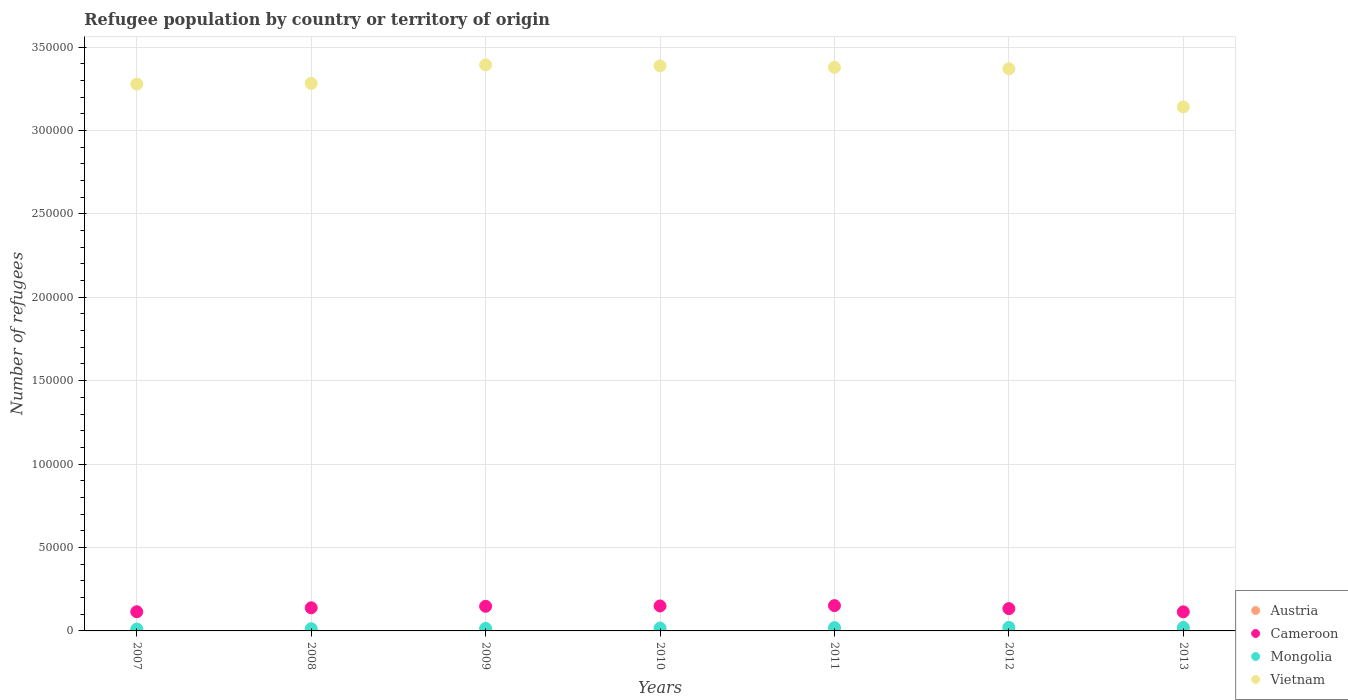How many different coloured dotlines are there?
Offer a very short reply. 4. Is the number of dotlines equal to the number of legend labels?
Your answer should be very brief. Yes. What is the number of refugees in Cameroon in 2008?
Make the answer very short. 1.39e+04. Across all years, what is the minimum number of refugees in Mongolia?
Give a very brief answer. 1101. In which year was the number of refugees in Vietnam minimum?
Give a very brief answer. 2013. What is the total number of refugees in Cameroon in the graph?
Give a very brief answer. 9.51e+04. What is the difference between the number of refugees in Cameroon in 2010 and that in 2013?
Give a very brief answer. 3521. What is the difference between the number of refugees in Austria in 2013 and the number of refugees in Vietnam in 2010?
Offer a very short reply. -3.39e+05. What is the average number of refugees in Cameroon per year?
Keep it short and to the point. 1.36e+04. In the year 2013, what is the difference between the number of refugees in Cameroon and number of refugees in Mongolia?
Ensure brevity in your answer.  9378. What is the ratio of the number of refugees in Austria in 2010 to that in 2012?
Your answer should be very brief. 0.83. Is the number of refugees in Austria in 2009 less than that in 2012?
Your answer should be compact. No. What is the difference between the highest and the second highest number of refugees in Cameroon?
Your response must be concise. 200. What is the difference between the highest and the lowest number of refugees in Mongolia?
Ensure brevity in your answer.  1013. Is the sum of the number of refugees in Austria in 2011 and 2012 greater than the maximum number of refugees in Cameroon across all years?
Your answer should be very brief. No. Is it the case that in every year, the sum of the number of refugees in Cameroon and number of refugees in Vietnam  is greater than the number of refugees in Austria?
Make the answer very short. Yes. Is the number of refugees in Mongolia strictly greater than the number of refugees in Austria over the years?
Provide a succinct answer. Yes. Is the number of refugees in Austria strictly less than the number of refugees in Mongolia over the years?
Provide a succinct answer. Yes. What is the difference between two consecutive major ticks on the Y-axis?
Your answer should be compact. 5.00e+04. Does the graph contain any zero values?
Offer a very short reply. No. Does the graph contain grids?
Your response must be concise. Yes. How many legend labels are there?
Offer a terse response. 4. What is the title of the graph?
Make the answer very short. Refugee population by country or territory of origin. Does "Monaco" appear as one of the legend labels in the graph?
Your answer should be very brief. No. What is the label or title of the Y-axis?
Your answer should be compact. Number of refugees. What is the Number of refugees of Cameroon in 2007?
Ensure brevity in your answer.  1.15e+04. What is the Number of refugees in Mongolia in 2007?
Give a very brief answer. 1101. What is the Number of refugees of Vietnam in 2007?
Your answer should be very brief. 3.28e+05. What is the Number of refugees of Austria in 2008?
Your answer should be compact. 14. What is the Number of refugees of Cameroon in 2008?
Keep it short and to the point. 1.39e+04. What is the Number of refugees of Mongolia in 2008?
Your answer should be compact. 1333. What is the Number of refugees in Vietnam in 2008?
Keep it short and to the point. 3.28e+05. What is the Number of refugees of Austria in 2009?
Give a very brief answer. 12. What is the Number of refugees in Cameroon in 2009?
Make the answer very short. 1.48e+04. What is the Number of refugees in Mongolia in 2009?
Offer a very short reply. 1495. What is the Number of refugees of Vietnam in 2009?
Ensure brevity in your answer.  3.39e+05. What is the Number of refugees of Austria in 2010?
Keep it short and to the point. 10. What is the Number of refugees in Cameroon in 2010?
Give a very brief answer. 1.50e+04. What is the Number of refugees of Mongolia in 2010?
Your answer should be very brief. 1724. What is the Number of refugees in Vietnam in 2010?
Make the answer very short. 3.39e+05. What is the Number of refugees of Cameroon in 2011?
Offer a very short reply. 1.52e+04. What is the Number of refugees of Mongolia in 2011?
Provide a short and direct response. 1985. What is the Number of refugees of Vietnam in 2011?
Your response must be concise. 3.38e+05. What is the Number of refugees of Cameroon in 2012?
Provide a short and direct response. 1.34e+04. What is the Number of refugees in Mongolia in 2012?
Provide a succinct answer. 2114. What is the Number of refugees of Vietnam in 2012?
Ensure brevity in your answer.  3.37e+05. What is the Number of refugees in Austria in 2013?
Your answer should be very brief. 10. What is the Number of refugees of Cameroon in 2013?
Provide a short and direct response. 1.14e+04. What is the Number of refugees of Mongolia in 2013?
Make the answer very short. 2064. What is the Number of refugees in Vietnam in 2013?
Offer a terse response. 3.14e+05. Across all years, what is the maximum Number of refugees in Cameroon?
Provide a succinct answer. 1.52e+04. Across all years, what is the maximum Number of refugees in Mongolia?
Your response must be concise. 2114. Across all years, what is the maximum Number of refugees of Vietnam?
Provide a short and direct response. 3.39e+05. Across all years, what is the minimum Number of refugees in Cameroon?
Provide a succinct answer. 1.14e+04. Across all years, what is the minimum Number of refugees in Mongolia?
Your answer should be very brief. 1101. Across all years, what is the minimum Number of refugees in Vietnam?
Make the answer very short. 3.14e+05. What is the total Number of refugees in Austria in the graph?
Your answer should be compact. 92. What is the total Number of refugees of Cameroon in the graph?
Provide a short and direct response. 9.51e+04. What is the total Number of refugees in Mongolia in the graph?
Keep it short and to the point. 1.18e+04. What is the total Number of refugees in Vietnam in the graph?
Provide a succinct answer. 2.32e+06. What is the difference between the Number of refugees of Cameroon in 2007 and that in 2008?
Keep it short and to the point. -2362. What is the difference between the Number of refugees in Mongolia in 2007 and that in 2008?
Offer a terse response. -232. What is the difference between the Number of refugees of Vietnam in 2007 and that in 2008?
Provide a succinct answer. -407. What is the difference between the Number of refugees in Austria in 2007 and that in 2009?
Provide a succinct answer. 11. What is the difference between the Number of refugees in Cameroon in 2007 and that in 2009?
Keep it short and to the point. -3258. What is the difference between the Number of refugees of Mongolia in 2007 and that in 2009?
Provide a short and direct response. -394. What is the difference between the Number of refugees in Vietnam in 2007 and that in 2009?
Your answer should be compact. -1.15e+04. What is the difference between the Number of refugees of Austria in 2007 and that in 2010?
Keep it short and to the point. 13. What is the difference between the Number of refugees in Cameroon in 2007 and that in 2010?
Your answer should be compact. -3455. What is the difference between the Number of refugees in Mongolia in 2007 and that in 2010?
Make the answer very short. -623. What is the difference between the Number of refugees in Vietnam in 2007 and that in 2010?
Your answer should be very brief. -1.09e+04. What is the difference between the Number of refugees in Cameroon in 2007 and that in 2011?
Your answer should be compact. -3655. What is the difference between the Number of refugees of Mongolia in 2007 and that in 2011?
Keep it short and to the point. -884. What is the difference between the Number of refugees in Vietnam in 2007 and that in 2011?
Offer a very short reply. -1.01e+04. What is the difference between the Number of refugees of Cameroon in 2007 and that in 2012?
Keep it short and to the point. -1874. What is the difference between the Number of refugees in Mongolia in 2007 and that in 2012?
Your answer should be compact. -1013. What is the difference between the Number of refugees of Vietnam in 2007 and that in 2012?
Keep it short and to the point. -9163. What is the difference between the Number of refugees of Austria in 2007 and that in 2013?
Provide a short and direct response. 13. What is the difference between the Number of refugees of Mongolia in 2007 and that in 2013?
Make the answer very short. -963. What is the difference between the Number of refugees of Vietnam in 2007 and that in 2013?
Provide a short and direct response. 1.37e+04. What is the difference between the Number of refugees of Austria in 2008 and that in 2009?
Your response must be concise. 2. What is the difference between the Number of refugees of Cameroon in 2008 and that in 2009?
Ensure brevity in your answer.  -896. What is the difference between the Number of refugees in Mongolia in 2008 and that in 2009?
Keep it short and to the point. -162. What is the difference between the Number of refugees of Vietnam in 2008 and that in 2009?
Offer a very short reply. -1.11e+04. What is the difference between the Number of refugees of Cameroon in 2008 and that in 2010?
Offer a very short reply. -1093. What is the difference between the Number of refugees in Mongolia in 2008 and that in 2010?
Offer a terse response. -391. What is the difference between the Number of refugees of Vietnam in 2008 and that in 2010?
Your response must be concise. -1.05e+04. What is the difference between the Number of refugees in Cameroon in 2008 and that in 2011?
Your answer should be compact. -1293. What is the difference between the Number of refugees in Mongolia in 2008 and that in 2011?
Ensure brevity in your answer.  -652. What is the difference between the Number of refugees of Vietnam in 2008 and that in 2011?
Keep it short and to the point. -9646. What is the difference between the Number of refugees in Austria in 2008 and that in 2012?
Your answer should be very brief. 2. What is the difference between the Number of refugees in Cameroon in 2008 and that in 2012?
Your response must be concise. 488. What is the difference between the Number of refugees of Mongolia in 2008 and that in 2012?
Ensure brevity in your answer.  -781. What is the difference between the Number of refugees in Vietnam in 2008 and that in 2012?
Keep it short and to the point. -8756. What is the difference between the Number of refugees of Cameroon in 2008 and that in 2013?
Your answer should be compact. 2428. What is the difference between the Number of refugees of Mongolia in 2008 and that in 2013?
Offer a terse response. -731. What is the difference between the Number of refugees of Vietnam in 2008 and that in 2013?
Ensure brevity in your answer.  1.41e+04. What is the difference between the Number of refugees of Austria in 2009 and that in 2010?
Your response must be concise. 2. What is the difference between the Number of refugees of Cameroon in 2009 and that in 2010?
Your response must be concise. -197. What is the difference between the Number of refugees in Mongolia in 2009 and that in 2010?
Provide a short and direct response. -229. What is the difference between the Number of refugees in Vietnam in 2009 and that in 2010?
Keep it short and to the point. 591. What is the difference between the Number of refugees of Cameroon in 2009 and that in 2011?
Provide a succinct answer. -397. What is the difference between the Number of refugees in Mongolia in 2009 and that in 2011?
Your answer should be compact. -490. What is the difference between the Number of refugees in Vietnam in 2009 and that in 2011?
Give a very brief answer. 1460. What is the difference between the Number of refugees in Austria in 2009 and that in 2012?
Provide a short and direct response. 0. What is the difference between the Number of refugees of Cameroon in 2009 and that in 2012?
Keep it short and to the point. 1384. What is the difference between the Number of refugees in Mongolia in 2009 and that in 2012?
Your answer should be compact. -619. What is the difference between the Number of refugees in Vietnam in 2009 and that in 2012?
Ensure brevity in your answer.  2350. What is the difference between the Number of refugees of Austria in 2009 and that in 2013?
Your answer should be very brief. 2. What is the difference between the Number of refugees in Cameroon in 2009 and that in 2013?
Give a very brief answer. 3324. What is the difference between the Number of refugees in Mongolia in 2009 and that in 2013?
Offer a very short reply. -569. What is the difference between the Number of refugees of Vietnam in 2009 and that in 2013?
Keep it short and to the point. 2.52e+04. What is the difference between the Number of refugees in Austria in 2010 and that in 2011?
Keep it short and to the point. -1. What is the difference between the Number of refugees of Cameroon in 2010 and that in 2011?
Provide a succinct answer. -200. What is the difference between the Number of refugees of Mongolia in 2010 and that in 2011?
Your answer should be compact. -261. What is the difference between the Number of refugees of Vietnam in 2010 and that in 2011?
Provide a short and direct response. 869. What is the difference between the Number of refugees in Cameroon in 2010 and that in 2012?
Provide a succinct answer. 1581. What is the difference between the Number of refugees in Mongolia in 2010 and that in 2012?
Offer a terse response. -390. What is the difference between the Number of refugees in Vietnam in 2010 and that in 2012?
Ensure brevity in your answer.  1759. What is the difference between the Number of refugees in Cameroon in 2010 and that in 2013?
Your answer should be very brief. 3521. What is the difference between the Number of refugees in Mongolia in 2010 and that in 2013?
Provide a short and direct response. -340. What is the difference between the Number of refugees of Vietnam in 2010 and that in 2013?
Offer a terse response. 2.46e+04. What is the difference between the Number of refugees of Austria in 2011 and that in 2012?
Keep it short and to the point. -1. What is the difference between the Number of refugees in Cameroon in 2011 and that in 2012?
Ensure brevity in your answer.  1781. What is the difference between the Number of refugees in Mongolia in 2011 and that in 2012?
Offer a very short reply. -129. What is the difference between the Number of refugees in Vietnam in 2011 and that in 2012?
Keep it short and to the point. 890. What is the difference between the Number of refugees of Austria in 2011 and that in 2013?
Keep it short and to the point. 1. What is the difference between the Number of refugees of Cameroon in 2011 and that in 2013?
Give a very brief answer. 3721. What is the difference between the Number of refugees of Mongolia in 2011 and that in 2013?
Your answer should be compact. -79. What is the difference between the Number of refugees in Vietnam in 2011 and that in 2013?
Ensure brevity in your answer.  2.37e+04. What is the difference between the Number of refugees of Cameroon in 2012 and that in 2013?
Provide a succinct answer. 1940. What is the difference between the Number of refugees of Vietnam in 2012 and that in 2013?
Provide a succinct answer. 2.28e+04. What is the difference between the Number of refugees of Austria in 2007 and the Number of refugees of Cameroon in 2008?
Your response must be concise. -1.38e+04. What is the difference between the Number of refugees of Austria in 2007 and the Number of refugees of Mongolia in 2008?
Make the answer very short. -1310. What is the difference between the Number of refugees in Austria in 2007 and the Number of refugees in Vietnam in 2008?
Offer a very short reply. -3.28e+05. What is the difference between the Number of refugees of Cameroon in 2007 and the Number of refugees of Mongolia in 2008?
Offer a terse response. 1.02e+04. What is the difference between the Number of refugees of Cameroon in 2007 and the Number of refugees of Vietnam in 2008?
Your answer should be very brief. -3.17e+05. What is the difference between the Number of refugees of Mongolia in 2007 and the Number of refugees of Vietnam in 2008?
Offer a terse response. -3.27e+05. What is the difference between the Number of refugees of Austria in 2007 and the Number of refugees of Cameroon in 2009?
Give a very brief answer. -1.47e+04. What is the difference between the Number of refugees of Austria in 2007 and the Number of refugees of Mongolia in 2009?
Keep it short and to the point. -1472. What is the difference between the Number of refugees of Austria in 2007 and the Number of refugees of Vietnam in 2009?
Offer a very short reply. -3.39e+05. What is the difference between the Number of refugees in Cameroon in 2007 and the Number of refugees in Mongolia in 2009?
Make the answer very short. 1.00e+04. What is the difference between the Number of refugees of Cameroon in 2007 and the Number of refugees of Vietnam in 2009?
Keep it short and to the point. -3.28e+05. What is the difference between the Number of refugees in Mongolia in 2007 and the Number of refugees in Vietnam in 2009?
Give a very brief answer. -3.38e+05. What is the difference between the Number of refugees of Austria in 2007 and the Number of refugees of Cameroon in 2010?
Provide a short and direct response. -1.49e+04. What is the difference between the Number of refugees in Austria in 2007 and the Number of refugees in Mongolia in 2010?
Ensure brevity in your answer.  -1701. What is the difference between the Number of refugees of Austria in 2007 and the Number of refugees of Vietnam in 2010?
Offer a terse response. -3.39e+05. What is the difference between the Number of refugees in Cameroon in 2007 and the Number of refugees in Mongolia in 2010?
Offer a terse response. 9784. What is the difference between the Number of refugees in Cameroon in 2007 and the Number of refugees in Vietnam in 2010?
Ensure brevity in your answer.  -3.27e+05. What is the difference between the Number of refugees in Mongolia in 2007 and the Number of refugees in Vietnam in 2010?
Keep it short and to the point. -3.38e+05. What is the difference between the Number of refugees in Austria in 2007 and the Number of refugees in Cameroon in 2011?
Your response must be concise. -1.51e+04. What is the difference between the Number of refugees in Austria in 2007 and the Number of refugees in Mongolia in 2011?
Offer a terse response. -1962. What is the difference between the Number of refugees of Austria in 2007 and the Number of refugees of Vietnam in 2011?
Give a very brief answer. -3.38e+05. What is the difference between the Number of refugees of Cameroon in 2007 and the Number of refugees of Mongolia in 2011?
Give a very brief answer. 9523. What is the difference between the Number of refugees of Cameroon in 2007 and the Number of refugees of Vietnam in 2011?
Your answer should be very brief. -3.26e+05. What is the difference between the Number of refugees of Mongolia in 2007 and the Number of refugees of Vietnam in 2011?
Provide a short and direct response. -3.37e+05. What is the difference between the Number of refugees in Austria in 2007 and the Number of refugees in Cameroon in 2012?
Offer a very short reply. -1.34e+04. What is the difference between the Number of refugees in Austria in 2007 and the Number of refugees in Mongolia in 2012?
Give a very brief answer. -2091. What is the difference between the Number of refugees in Austria in 2007 and the Number of refugees in Vietnam in 2012?
Make the answer very short. -3.37e+05. What is the difference between the Number of refugees in Cameroon in 2007 and the Number of refugees in Mongolia in 2012?
Ensure brevity in your answer.  9394. What is the difference between the Number of refugees in Cameroon in 2007 and the Number of refugees in Vietnam in 2012?
Make the answer very short. -3.25e+05. What is the difference between the Number of refugees of Mongolia in 2007 and the Number of refugees of Vietnam in 2012?
Ensure brevity in your answer.  -3.36e+05. What is the difference between the Number of refugees in Austria in 2007 and the Number of refugees in Cameroon in 2013?
Give a very brief answer. -1.14e+04. What is the difference between the Number of refugees of Austria in 2007 and the Number of refugees of Mongolia in 2013?
Your answer should be very brief. -2041. What is the difference between the Number of refugees in Austria in 2007 and the Number of refugees in Vietnam in 2013?
Provide a succinct answer. -3.14e+05. What is the difference between the Number of refugees of Cameroon in 2007 and the Number of refugees of Mongolia in 2013?
Provide a succinct answer. 9444. What is the difference between the Number of refugees of Cameroon in 2007 and the Number of refugees of Vietnam in 2013?
Provide a short and direct response. -3.03e+05. What is the difference between the Number of refugees of Mongolia in 2007 and the Number of refugees of Vietnam in 2013?
Offer a terse response. -3.13e+05. What is the difference between the Number of refugees of Austria in 2008 and the Number of refugees of Cameroon in 2009?
Provide a succinct answer. -1.48e+04. What is the difference between the Number of refugees of Austria in 2008 and the Number of refugees of Mongolia in 2009?
Offer a very short reply. -1481. What is the difference between the Number of refugees in Austria in 2008 and the Number of refugees in Vietnam in 2009?
Your response must be concise. -3.39e+05. What is the difference between the Number of refugees of Cameroon in 2008 and the Number of refugees of Mongolia in 2009?
Offer a very short reply. 1.24e+04. What is the difference between the Number of refugees of Cameroon in 2008 and the Number of refugees of Vietnam in 2009?
Keep it short and to the point. -3.25e+05. What is the difference between the Number of refugees of Mongolia in 2008 and the Number of refugees of Vietnam in 2009?
Your answer should be compact. -3.38e+05. What is the difference between the Number of refugees in Austria in 2008 and the Number of refugees in Cameroon in 2010?
Your response must be concise. -1.49e+04. What is the difference between the Number of refugees in Austria in 2008 and the Number of refugees in Mongolia in 2010?
Make the answer very short. -1710. What is the difference between the Number of refugees of Austria in 2008 and the Number of refugees of Vietnam in 2010?
Give a very brief answer. -3.39e+05. What is the difference between the Number of refugees in Cameroon in 2008 and the Number of refugees in Mongolia in 2010?
Your answer should be very brief. 1.21e+04. What is the difference between the Number of refugees in Cameroon in 2008 and the Number of refugees in Vietnam in 2010?
Give a very brief answer. -3.25e+05. What is the difference between the Number of refugees in Mongolia in 2008 and the Number of refugees in Vietnam in 2010?
Provide a succinct answer. -3.37e+05. What is the difference between the Number of refugees of Austria in 2008 and the Number of refugees of Cameroon in 2011?
Give a very brief answer. -1.51e+04. What is the difference between the Number of refugees in Austria in 2008 and the Number of refugees in Mongolia in 2011?
Your answer should be compact. -1971. What is the difference between the Number of refugees of Austria in 2008 and the Number of refugees of Vietnam in 2011?
Your answer should be very brief. -3.38e+05. What is the difference between the Number of refugees of Cameroon in 2008 and the Number of refugees of Mongolia in 2011?
Your answer should be very brief. 1.19e+04. What is the difference between the Number of refugees of Cameroon in 2008 and the Number of refugees of Vietnam in 2011?
Your answer should be very brief. -3.24e+05. What is the difference between the Number of refugees of Mongolia in 2008 and the Number of refugees of Vietnam in 2011?
Offer a terse response. -3.36e+05. What is the difference between the Number of refugees in Austria in 2008 and the Number of refugees in Cameroon in 2012?
Ensure brevity in your answer.  -1.34e+04. What is the difference between the Number of refugees in Austria in 2008 and the Number of refugees in Mongolia in 2012?
Offer a terse response. -2100. What is the difference between the Number of refugees in Austria in 2008 and the Number of refugees in Vietnam in 2012?
Make the answer very short. -3.37e+05. What is the difference between the Number of refugees of Cameroon in 2008 and the Number of refugees of Mongolia in 2012?
Offer a terse response. 1.18e+04. What is the difference between the Number of refugees in Cameroon in 2008 and the Number of refugees in Vietnam in 2012?
Make the answer very short. -3.23e+05. What is the difference between the Number of refugees in Mongolia in 2008 and the Number of refugees in Vietnam in 2012?
Ensure brevity in your answer.  -3.36e+05. What is the difference between the Number of refugees of Austria in 2008 and the Number of refugees of Cameroon in 2013?
Offer a terse response. -1.14e+04. What is the difference between the Number of refugees in Austria in 2008 and the Number of refugees in Mongolia in 2013?
Offer a terse response. -2050. What is the difference between the Number of refugees of Austria in 2008 and the Number of refugees of Vietnam in 2013?
Offer a very short reply. -3.14e+05. What is the difference between the Number of refugees of Cameroon in 2008 and the Number of refugees of Mongolia in 2013?
Ensure brevity in your answer.  1.18e+04. What is the difference between the Number of refugees of Cameroon in 2008 and the Number of refugees of Vietnam in 2013?
Provide a succinct answer. -3.00e+05. What is the difference between the Number of refugees in Mongolia in 2008 and the Number of refugees in Vietnam in 2013?
Give a very brief answer. -3.13e+05. What is the difference between the Number of refugees in Austria in 2009 and the Number of refugees in Cameroon in 2010?
Your answer should be compact. -1.50e+04. What is the difference between the Number of refugees in Austria in 2009 and the Number of refugees in Mongolia in 2010?
Make the answer very short. -1712. What is the difference between the Number of refugees in Austria in 2009 and the Number of refugees in Vietnam in 2010?
Provide a short and direct response. -3.39e+05. What is the difference between the Number of refugees of Cameroon in 2009 and the Number of refugees of Mongolia in 2010?
Your response must be concise. 1.30e+04. What is the difference between the Number of refugees of Cameroon in 2009 and the Number of refugees of Vietnam in 2010?
Give a very brief answer. -3.24e+05. What is the difference between the Number of refugees of Mongolia in 2009 and the Number of refugees of Vietnam in 2010?
Keep it short and to the point. -3.37e+05. What is the difference between the Number of refugees of Austria in 2009 and the Number of refugees of Cameroon in 2011?
Offer a very short reply. -1.52e+04. What is the difference between the Number of refugees of Austria in 2009 and the Number of refugees of Mongolia in 2011?
Keep it short and to the point. -1973. What is the difference between the Number of refugees of Austria in 2009 and the Number of refugees of Vietnam in 2011?
Offer a terse response. -3.38e+05. What is the difference between the Number of refugees in Cameroon in 2009 and the Number of refugees in Mongolia in 2011?
Your answer should be very brief. 1.28e+04. What is the difference between the Number of refugees in Cameroon in 2009 and the Number of refugees in Vietnam in 2011?
Your response must be concise. -3.23e+05. What is the difference between the Number of refugees of Mongolia in 2009 and the Number of refugees of Vietnam in 2011?
Your answer should be very brief. -3.36e+05. What is the difference between the Number of refugees in Austria in 2009 and the Number of refugees in Cameroon in 2012?
Your answer should be compact. -1.34e+04. What is the difference between the Number of refugees in Austria in 2009 and the Number of refugees in Mongolia in 2012?
Make the answer very short. -2102. What is the difference between the Number of refugees in Austria in 2009 and the Number of refugees in Vietnam in 2012?
Offer a terse response. -3.37e+05. What is the difference between the Number of refugees of Cameroon in 2009 and the Number of refugees of Mongolia in 2012?
Offer a terse response. 1.27e+04. What is the difference between the Number of refugees of Cameroon in 2009 and the Number of refugees of Vietnam in 2012?
Your response must be concise. -3.22e+05. What is the difference between the Number of refugees of Mongolia in 2009 and the Number of refugees of Vietnam in 2012?
Keep it short and to the point. -3.35e+05. What is the difference between the Number of refugees in Austria in 2009 and the Number of refugees in Cameroon in 2013?
Offer a terse response. -1.14e+04. What is the difference between the Number of refugees of Austria in 2009 and the Number of refugees of Mongolia in 2013?
Your answer should be very brief. -2052. What is the difference between the Number of refugees of Austria in 2009 and the Number of refugees of Vietnam in 2013?
Provide a succinct answer. -3.14e+05. What is the difference between the Number of refugees in Cameroon in 2009 and the Number of refugees in Mongolia in 2013?
Your answer should be compact. 1.27e+04. What is the difference between the Number of refugees of Cameroon in 2009 and the Number of refugees of Vietnam in 2013?
Your answer should be compact. -2.99e+05. What is the difference between the Number of refugees in Mongolia in 2009 and the Number of refugees in Vietnam in 2013?
Provide a succinct answer. -3.13e+05. What is the difference between the Number of refugees in Austria in 2010 and the Number of refugees in Cameroon in 2011?
Your response must be concise. -1.52e+04. What is the difference between the Number of refugees of Austria in 2010 and the Number of refugees of Mongolia in 2011?
Your answer should be compact. -1975. What is the difference between the Number of refugees of Austria in 2010 and the Number of refugees of Vietnam in 2011?
Make the answer very short. -3.38e+05. What is the difference between the Number of refugees of Cameroon in 2010 and the Number of refugees of Mongolia in 2011?
Your answer should be compact. 1.30e+04. What is the difference between the Number of refugees of Cameroon in 2010 and the Number of refugees of Vietnam in 2011?
Offer a very short reply. -3.23e+05. What is the difference between the Number of refugees of Mongolia in 2010 and the Number of refugees of Vietnam in 2011?
Your answer should be compact. -3.36e+05. What is the difference between the Number of refugees of Austria in 2010 and the Number of refugees of Cameroon in 2012?
Your response must be concise. -1.34e+04. What is the difference between the Number of refugees in Austria in 2010 and the Number of refugees in Mongolia in 2012?
Your response must be concise. -2104. What is the difference between the Number of refugees in Austria in 2010 and the Number of refugees in Vietnam in 2012?
Your answer should be compact. -3.37e+05. What is the difference between the Number of refugees of Cameroon in 2010 and the Number of refugees of Mongolia in 2012?
Your answer should be very brief. 1.28e+04. What is the difference between the Number of refugees in Cameroon in 2010 and the Number of refugees in Vietnam in 2012?
Provide a succinct answer. -3.22e+05. What is the difference between the Number of refugees in Mongolia in 2010 and the Number of refugees in Vietnam in 2012?
Offer a terse response. -3.35e+05. What is the difference between the Number of refugees in Austria in 2010 and the Number of refugees in Cameroon in 2013?
Make the answer very short. -1.14e+04. What is the difference between the Number of refugees in Austria in 2010 and the Number of refugees in Mongolia in 2013?
Give a very brief answer. -2054. What is the difference between the Number of refugees of Austria in 2010 and the Number of refugees of Vietnam in 2013?
Provide a short and direct response. -3.14e+05. What is the difference between the Number of refugees of Cameroon in 2010 and the Number of refugees of Mongolia in 2013?
Provide a short and direct response. 1.29e+04. What is the difference between the Number of refugees in Cameroon in 2010 and the Number of refugees in Vietnam in 2013?
Keep it short and to the point. -2.99e+05. What is the difference between the Number of refugees in Mongolia in 2010 and the Number of refugees in Vietnam in 2013?
Provide a short and direct response. -3.12e+05. What is the difference between the Number of refugees of Austria in 2011 and the Number of refugees of Cameroon in 2012?
Ensure brevity in your answer.  -1.34e+04. What is the difference between the Number of refugees in Austria in 2011 and the Number of refugees in Mongolia in 2012?
Your answer should be compact. -2103. What is the difference between the Number of refugees in Austria in 2011 and the Number of refugees in Vietnam in 2012?
Your response must be concise. -3.37e+05. What is the difference between the Number of refugees of Cameroon in 2011 and the Number of refugees of Mongolia in 2012?
Your response must be concise. 1.30e+04. What is the difference between the Number of refugees in Cameroon in 2011 and the Number of refugees in Vietnam in 2012?
Offer a very short reply. -3.22e+05. What is the difference between the Number of refugees in Mongolia in 2011 and the Number of refugees in Vietnam in 2012?
Your answer should be very brief. -3.35e+05. What is the difference between the Number of refugees in Austria in 2011 and the Number of refugees in Cameroon in 2013?
Provide a succinct answer. -1.14e+04. What is the difference between the Number of refugees in Austria in 2011 and the Number of refugees in Mongolia in 2013?
Provide a short and direct response. -2053. What is the difference between the Number of refugees of Austria in 2011 and the Number of refugees of Vietnam in 2013?
Offer a very short reply. -3.14e+05. What is the difference between the Number of refugees in Cameroon in 2011 and the Number of refugees in Mongolia in 2013?
Your response must be concise. 1.31e+04. What is the difference between the Number of refugees in Cameroon in 2011 and the Number of refugees in Vietnam in 2013?
Ensure brevity in your answer.  -2.99e+05. What is the difference between the Number of refugees in Mongolia in 2011 and the Number of refugees in Vietnam in 2013?
Provide a short and direct response. -3.12e+05. What is the difference between the Number of refugees of Austria in 2012 and the Number of refugees of Cameroon in 2013?
Your response must be concise. -1.14e+04. What is the difference between the Number of refugees in Austria in 2012 and the Number of refugees in Mongolia in 2013?
Provide a short and direct response. -2052. What is the difference between the Number of refugees of Austria in 2012 and the Number of refugees of Vietnam in 2013?
Keep it short and to the point. -3.14e+05. What is the difference between the Number of refugees in Cameroon in 2012 and the Number of refugees in Mongolia in 2013?
Provide a short and direct response. 1.13e+04. What is the difference between the Number of refugees in Cameroon in 2012 and the Number of refugees in Vietnam in 2013?
Keep it short and to the point. -3.01e+05. What is the difference between the Number of refugees of Mongolia in 2012 and the Number of refugees of Vietnam in 2013?
Provide a succinct answer. -3.12e+05. What is the average Number of refugees of Austria per year?
Offer a terse response. 13.14. What is the average Number of refugees of Cameroon per year?
Offer a terse response. 1.36e+04. What is the average Number of refugees in Mongolia per year?
Your response must be concise. 1688. What is the average Number of refugees in Vietnam per year?
Your response must be concise. 3.32e+05. In the year 2007, what is the difference between the Number of refugees in Austria and Number of refugees in Cameroon?
Offer a very short reply. -1.15e+04. In the year 2007, what is the difference between the Number of refugees of Austria and Number of refugees of Mongolia?
Ensure brevity in your answer.  -1078. In the year 2007, what is the difference between the Number of refugees in Austria and Number of refugees in Vietnam?
Your answer should be very brief. -3.28e+05. In the year 2007, what is the difference between the Number of refugees in Cameroon and Number of refugees in Mongolia?
Your response must be concise. 1.04e+04. In the year 2007, what is the difference between the Number of refugees in Cameroon and Number of refugees in Vietnam?
Offer a very short reply. -3.16e+05. In the year 2007, what is the difference between the Number of refugees of Mongolia and Number of refugees of Vietnam?
Your answer should be compact. -3.27e+05. In the year 2008, what is the difference between the Number of refugees in Austria and Number of refugees in Cameroon?
Your answer should be compact. -1.39e+04. In the year 2008, what is the difference between the Number of refugees of Austria and Number of refugees of Mongolia?
Ensure brevity in your answer.  -1319. In the year 2008, what is the difference between the Number of refugees in Austria and Number of refugees in Vietnam?
Give a very brief answer. -3.28e+05. In the year 2008, what is the difference between the Number of refugees in Cameroon and Number of refugees in Mongolia?
Provide a succinct answer. 1.25e+04. In the year 2008, what is the difference between the Number of refugees in Cameroon and Number of refugees in Vietnam?
Your answer should be very brief. -3.14e+05. In the year 2008, what is the difference between the Number of refugees in Mongolia and Number of refugees in Vietnam?
Provide a succinct answer. -3.27e+05. In the year 2009, what is the difference between the Number of refugees in Austria and Number of refugees in Cameroon?
Keep it short and to the point. -1.48e+04. In the year 2009, what is the difference between the Number of refugees of Austria and Number of refugees of Mongolia?
Give a very brief answer. -1483. In the year 2009, what is the difference between the Number of refugees of Austria and Number of refugees of Vietnam?
Provide a succinct answer. -3.39e+05. In the year 2009, what is the difference between the Number of refugees of Cameroon and Number of refugees of Mongolia?
Provide a short and direct response. 1.33e+04. In the year 2009, what is the difference between the Number of refugees of Cameroon and Number of refugees of Vietnam?
Offer a terse response. -3.25e+05. In the year 2009, what is the difference between the Number of refugees in Mongolia and Number of refugees in Vietnam?
Keep it short and to the point. -3.38e+05. In the year 2010, what is the difference between the Number of refugees of Austria and Number of refugees of Cameroon?
Give a very brief answer. -1.50e+04. In the year 2010, what is the difference between the Number of refugees of Austria and Number of refugees of Mongolia?
Ensure brevity in your answer.  -1714. In the year 2010, what is the difference between the Number of refugees of Austria and Number of refugees of Vietnam?
Ensure brevity in your answer.  -3.39e+05. In the year 2010, what is the difference between the Number of refugees of Cameroon and Number of refugees of Mongolia?
Offer a very short reply. 1.32e+04. In the year 2010, what is the difference between the Number of refugees of Cameroon and Number of refugees of Vietnam?
Keep it short and to the point. -3.24e+05. In the year 2010, what is the difference between the Number of refugees in Mongolia and Number of refugees in Vietnam?
Keep it short and to the point. -3.37e+05. In the year 2011, what is the difference between the Number of refugees of Austria and Number of refugees of Cameroon?
Provide a short and direct response. -1.52e+04. In the year 2011, what is the difference between the Number of refugees in Austria and Number of refugees in Mongolia?
Your answer should be compact. -1974. In the year 2011, what is the difference between the Number of refugees of Austria and Number of refugees of Vietnam?
Provide a short and direct response. -3.38e+05. In the year 2011, what is the difference between the Number of refugees in Cameroon and Number of refugees in Mongolia?
Your answer should be compact. 1.32e+04. In the year 2011, what is the difference between the Number of refugees in Cameroon and Number of refugees in Vietnam?
Ensure brevity in your answer.  -3.23e+05. In the year 2011, what is the difference between the Number of refugees in Mongolia and Number of refugees in Vietnam?
Give a very brief answer. -3.36e+05. In the year 2012, what is the difference between the Number of refugees of Austria and Number of refugees of Cameroon?
Keep it short and to the point. -1.34e+04. In the year 2012, what is the difference between the Number of refugees of Austria and Number of refugees of Mongolia?
Provide a succinct answer. -2102. In the year 2012, what is the difference between the Number of refugees of Austria and Number of refugees of Vietnam?
Offer a very short reply. -3.37e+05. In the year 2012, what is the difference between the Number of refugees of Cameroon and Number of refugees of Mongolia?
Your answer should be very brief. 1.13e+04. In the year 2012, what is the difference between the Number of refugees in Cameroon and Number of refugees in Vietnam?
Offer a very short reply. -3.24e+05. In the year 2012, what is the difference between the Number of refugees in Mongolia and Number of refugees in Vietnam?
Keep it short and to the point. -3.35e+05. In the year 2013, what is the difference between the Number of refugees in Austria and Number of refugees in Cameroon?
Offer a terse response. -1.14e+04. In the year 2013, what is the difference between the Number of refugees in Austria and Number of refugees in Mongolia?
Your answer should be very brief. -2054. In the year 2013, what is the difference between the Number of refugees in Austria and Number of refugees in Vietnam?
Give a very brief answer. -3.14e+05. In the year 2013, what is the difference between the Number of refugees in Cameroon and Number of refugees in Mongolia?
Provide a succinct answer. 9378. In the year 2013, what is the difference between the Number of refugees in Cameroon and Number of refugees in Vietnam?
Keep it short and to the point. -3.03e+05. In the year 2013, what is the difference between the Number of refugees in Mongolia and Number of refugees in Vietnam?
Provide a short and direct response. -3.12e+05. What is the ratio of the Number of refugees of Austria in 2007 to that in 2008?
Ensure brevity in your answer.  1.64. What is the ratio of the Number of refugees in Cameroon in 2007 to that in 2008?
Offer a terse response. 0.83. What is the ratio of the Number of refugees in Mongolia in 2007 to that in 2008?
Keep it short and to the point. 0.83. What is the ratio of the Number of refugees of Austria in 2007 to that in 2009?
Make the answer very short. 1.92. What is the ratio of the Number of refugees of Cameroon in 2007 to that in 2009?
Keep it short and to the point. 0.78. What is the ratio of the Number of refugees in Mongolia in 2007 to that in 2009?
Your answer should be compact. 0.74. What is the ratio of the Number of refugees of Vietnam in 2007 to that in 2009?
Give a very brief answer. 0.97. What is the ratio of the Number of refugees of Austria in 2007 to that in 2010?
Offer a terse response. 2.3. What is the ratio of the Number of refugees in Cameroon in 2007 to that in 2010?
Your response must be concise. 0.77. What is the ratio of the Number of refugees of Mongolia in 2007 to that in 2010?
Give a very brief answer. 0.64. What is the ratio of the Number of refugees of Vietnam in 2007 to that in 2010?
Your answer should be compact. 0.97. What is the ratio of the Number of refugees of Austria in 2007 to that in 2011?
Offer a terse response. 2.09. What is the ratio of the Number of refugees in Cameroon in 2007 to that in 2011?
Your response must be concise. 0.76. What is the ratio of the Number of refugees of Mongolia in 2007 to that in 2011?
Your response must be concise. 0.55. What is the ratio of the Number of refugees in Vietnam in 2007 to that in 2011?
Offer a very short reply. 0.97. What is the ratio of the Number of refugees of Austria in 2007 to that in 2012?
Your answer should be compact. 1.92. What is the ratio of the Number of refugees of Cameroon in 2007 to that in 2012?
Ensure brevity in your answer.  0.86. What is the ratio of the Number of refugees in Mongolia in 2007 to that in 2012?
Your answer should be compact. 0.52. What is the ratio of the Number of refugees of Vietnam in 2007 to that in 2012?
Your answer should be compact. 0.97. What is the ratio of the Number of refugees in Mongolia in 2007 to that in 2013?
Keep it short and to the point. 0.53. What is the ratio of the Number of refugees of Vietnam in 2007 to that in 2013?
Your answer should be very brief. 1.04. What is the ratio of the Number of refugees of Cameroon in 2008 to that in 2009?
Your response must be concise. 0.94. What is the ratio of the Number of refugees in Mongolia in 2008 to that in 2009?
Your answer should be compact. 0.89. What is the ratio of the Number of refugees of Vietnam in 2008 to that in 2009?
Ensure brevity in your answer.  0.97. What is the ratio of the Number of refugees in Austria in 2008 to that in 2010?
Your answer should be compact. 1.4. What is the ratio of the Number of refugees in Cameroon in 2008 to that in 2010?
Your answer should be compact. 0.93. What is the ratio of the Number of refugees of Mongolia in 2008 to that in 2010?
Give a very brief answer. 0.77. What is the ratio of the Number of refugees in Vietnam in 2008 to that in 2010?
Offer a very short reply. 0.97. What is the ratio of the Number of refugees in Austria in 2008 to that in 2011?
Make the answer very short. 1.27. What is the ratio of the Number of refugees of Cameroon in 2008 to that in 2011?
Make the answer very short. 0.91. What is the ratio of the Number of refugees of Mongolia in 2008 to that in 2011?
Provide a succinct answer. 0.67. What is the ratio of the Number of refugees of Vietnam in 2008 to that in 2011?
Your answer should be compact. 0.97. What is the ratio of the Number of refugees in Cameroon in 2008 to that in 2012?
Give a very brief answer. 1.04. What is the ratio of the Number of refugees in Mongolia in 2008 to that in 2012?
Provide a short and direct response. 0.63. What is the ratio of the Number of refugees in Cameroon in 2008 to that in 2013?
Provide a succinct answer. 1.21. What is the ratio of the Number of refugees in Mongolia in 2008 to that in 2013?
Your answer should be very brief. 0.65. What is the ratio of the Number of refugees of Vietnam in 2008 to that in 2013?
Offer a very short reply. 1.04. What is the ratio of the Number of refugees of Austria in 2009 to that in 2010?
Your response must be concise. 1.2. What is the ratio of the Number of refugees in Cameroon in 2009 to that in 2010?
Your answer should be very brief. 0.99. What is the ratio of the Number of refugees of Mongolia in 2009 to that in 2010?
Your answer should be compact. 0.87. What is the ratio of the Number of refugees in Vietnam in 2009 to that in 2010?
Your response must be concise. 1. What is the ratio of the Number of refugees of Austria in 2009 to that in 2011?
Keep it short and to the point. 1.09. What is the ratio of the Number of refugees of Cameroon in 2009 to that in 2011?
Your answer should be very brief. 0.97. What is the ratio of the Number of refugees in Mongolia in 2009 to that in 2011?
Keep it short and to the point. 0.75. What is the ratio of the Number of refugees of Vietnam in 2009 to that in 2011?
Provide a succinct answer. 1. What is the ratio of the Number of refugees of Austria in 2009 to that in 2012?
Keep it short and to the point. 1. What is the ratio of the Number of refugees in Cameroon in 2009 to that in 2012?
Ensure brevity in your answer.  1.1. What is the ratio of the Number of refugees in Mongolia in 2009 to that in 2012?
Provide a short and direct response. 0.71. What is the ratio of the Number of refugees of Vietnam in 2009 to that in 2012?
Keep it short and to the point. 1.01. What is the ratio of the Number of refugees of Cameroon in 2009 to that in 2013?
Keep it short and to the point. 1.29. What is the ratio of the Number of refugees in Mongolia in 2009 to that in 2013?
Give a very brief answer. 0.72. What is the ratio of the Number of refugees of Vietnam in 2009 to that in 2013?
Make the answer very short. 1.08. What is the ratio of the Number of refugees in Mongolia in 2010 to that in 2011?
Offer a very short reply. 0.87. What is the ratio of the Number of refugees in Cameroon in 2010 to that in 2012?
Provide a succinct answer. 1.12. What is the ratio of the Number of refugees in Mongolia in 2010 to that in 2012?
Provide a short and direct response. 0.82. What is the ratio of the Number of refugees of Vietnam in 2010 to that in 2012?
Provide a succinct answer. 1.01. What is the ratio of the Number of refugees in Austria in 2010 to that in 2013?
Your answer should be very brief. 1. What is the ratio of the Number of refugees in Cameroon in 2010 to that in 2013?
Keep it short and to the point. 1.31. What is the ratio of the Number of refugees in Mongolia in 2010 to that in 2013?
Your answer should be very brief. 0.84. What is the ratio of the Number of refugees in Vietnam in 2010 to that in 2013?
Your response must be concise. 1.08. What is the ratio of the Number of refugees of Cameroon in 2011 to that in 2012?
Provide a succinct answer. 1.13. What is the ratio of the Number of refugees of Mongolia in 2011 to that in 2012?
Your answer should be compact. 0.94. What is the ratio of the Number of refugees of Austria in 2011 to that in 2013?
Your answer should be very brief. 1.1. What is the ratio of the Number of refugees in Cameroon in 2011 to that in 2013?
Provide a short and direct response. 1.33. What is the ratio of the Number of refugees of Mongolia in 2011 to that in 2013?
Your answer should be very brief. 0.96. What is the ratio of the Number of refugees of Vietnam in 2011 to that in 2013?
Provide a succinct answer. 1.08. What is the ratio of the Number of refugees in Austria in 2012 to that in 2013?
Give a very brief answer. 1.2. What is the ratio of the Number of refugees in Cameroon in 2012 to that in 2013?
Your answer should be compact. 1.17. What is the ratio of the Number of refugees in Mongolia in 2012 to that in 2013?
Offer a very short reply. 1.02. What is the ratio of the Number of refugees in Vietnam in 2012 to that in 2013?
Your answer should be very brief. 1.07. What is the difference between the highest and the second highest Number of refugees in Cameroon?
Ensure brevity in your answer.  200. What is the difference between the highest and the second highest Number of refugees in Vietnam?
Make the answer very short. 591. What is the difference between the highest and the lowest Number of refugees of Austria?
Keep it short and to the point. 13. What is the difference between the highest and the lowest Number of refugees of Cameroon?
Offer a terse response. 3721. What is the difference between the highest and the lowest Number of refugees of Mongolia?
Give a very brief answer. 1013. What is the difference between the highest and the lowest Number of refugees in Vietnam?
Your answer should be very brief. 2.52e+04. 